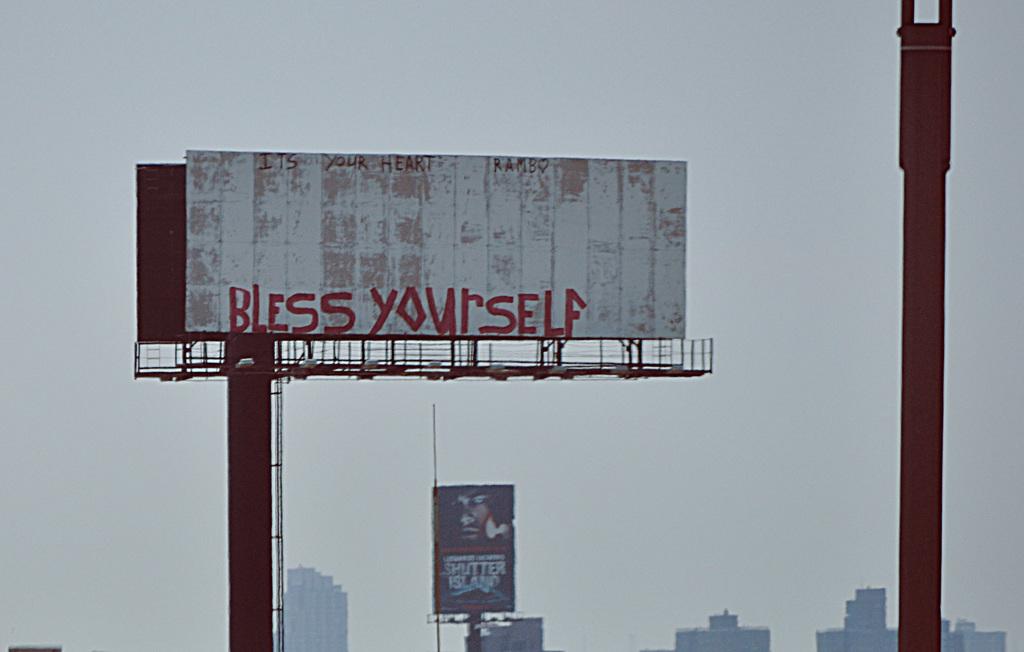What is the first word on this sign?
Ensure brevity in your answer.  Bless. 